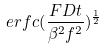<formula> <loc_0><loc_0><loc_500><loc_500>e r f c ( \frac { F D t } { \beta ^ { 2 } f ^ { 2 } } ) ^ { \frac { 1 } { 2 } }</formula> 